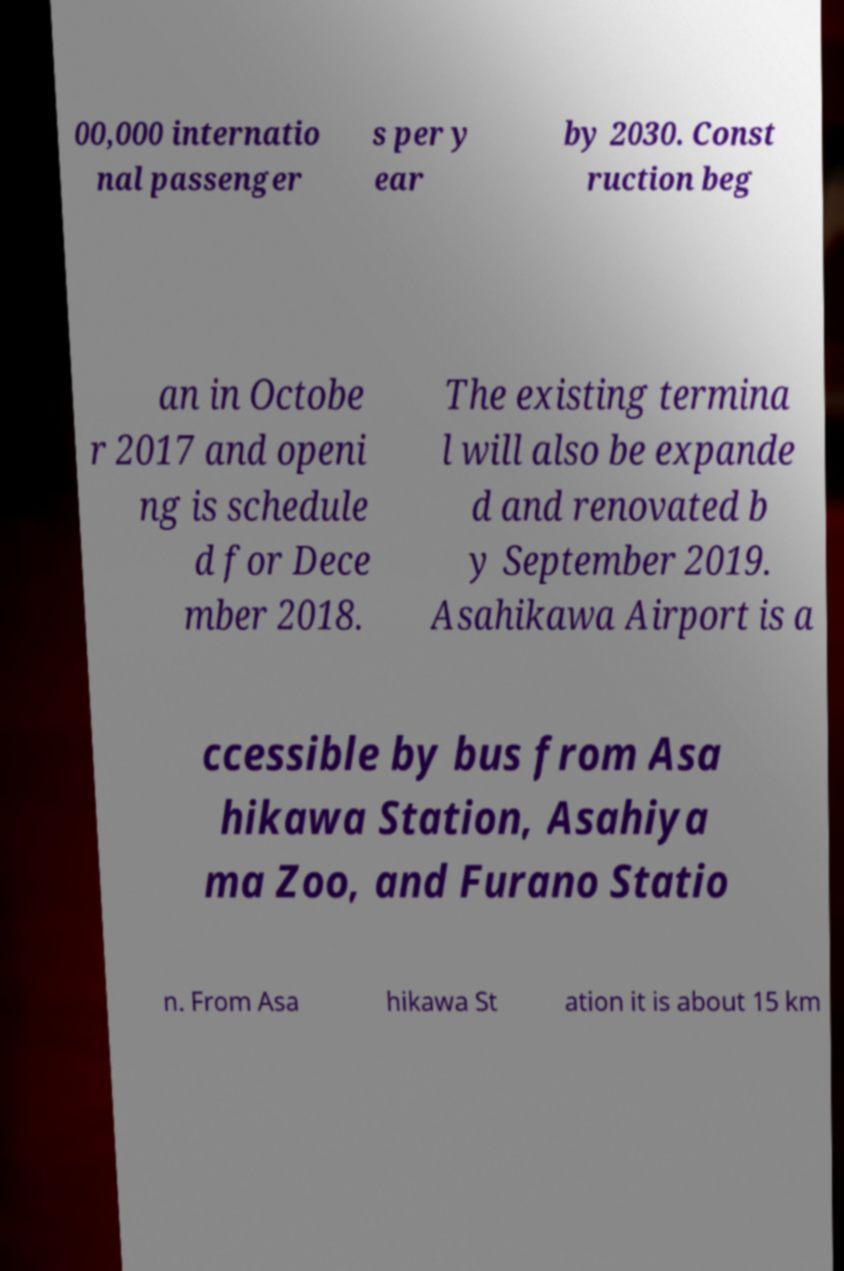Can you accurately transcribe the text from the provided image for me? 00,000 internatio nal passenger s per y ear by 2030. Const ruction beg an in Octobe r 2017 and openi ng is schedule d for Dece mber 2018. The existing termina l will also be expande d and renovated b y September 2019. Asahikawa Airport is a ccessible by bus from Asa hikawa Station, Asahiya ma Zoo, and Furano Statio n. From Asa hikawa St ation it is about 15 km 